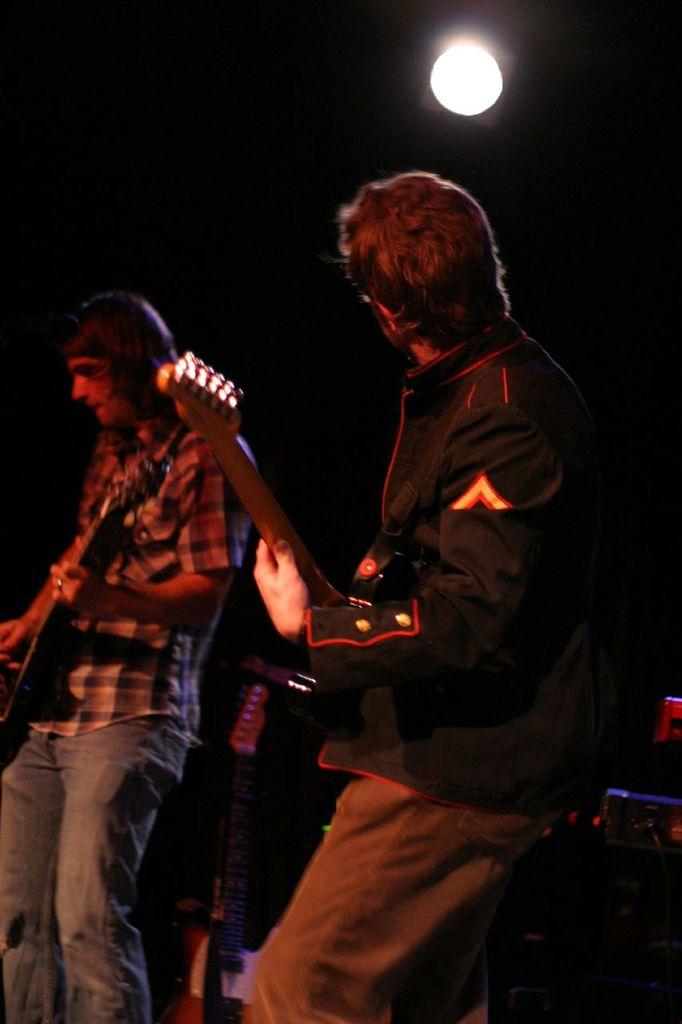How many people are in the image? There are two persons in the image. What are the two persons doing in the image? The two persons are playing guitar. Can you describe the lighting in the image? There is light in the image. How many dogs are present in the image? There are no dogs present in the image. What type of leather is being used by the friend in the image? There is no friend or leather present in the image. 